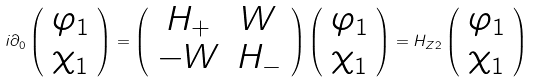Convert formula to latex. <formula><loc_0><loc_0><loc_500><loc_500>i \partial _ { 0 } \left ( { { \begin{array} { c } { \varphi _ { 1 } } \\ { \chi _ { 1 } } \end{array} } } \right ) = \left ( { { \begin{array} { c c } { H _ { + } } & W \\ { - W } & { H _ { - } } \end{array} } } \right ) \left ( { { \begin{array} { c } { \varphi _ { 1 } } \\ { \chi _ { 1 } } \end{array} } } \right ) = H _ { Z 2 } \left ( { { \begin{array} { c } { \varphi _ { 1 } } \\ { \chi _ { 1 } } \end{array} } } \right )</formula> 